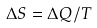Convert formula to latex. <formula><loc_0><loc_0><loc_500><loc_500>\Delta S = \Delta Q / T</formula> 